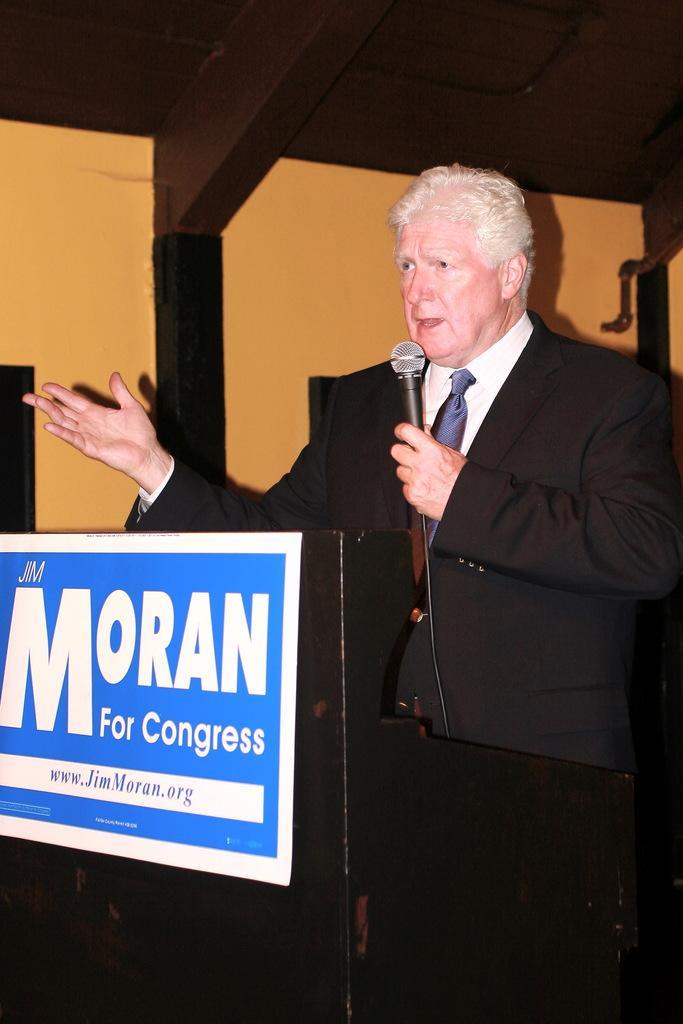In one or two sentences, can you explain what this image depicts? In this picture we can see a man wearing a black blazer, holding a mike in his hand and talking. This is a board. 